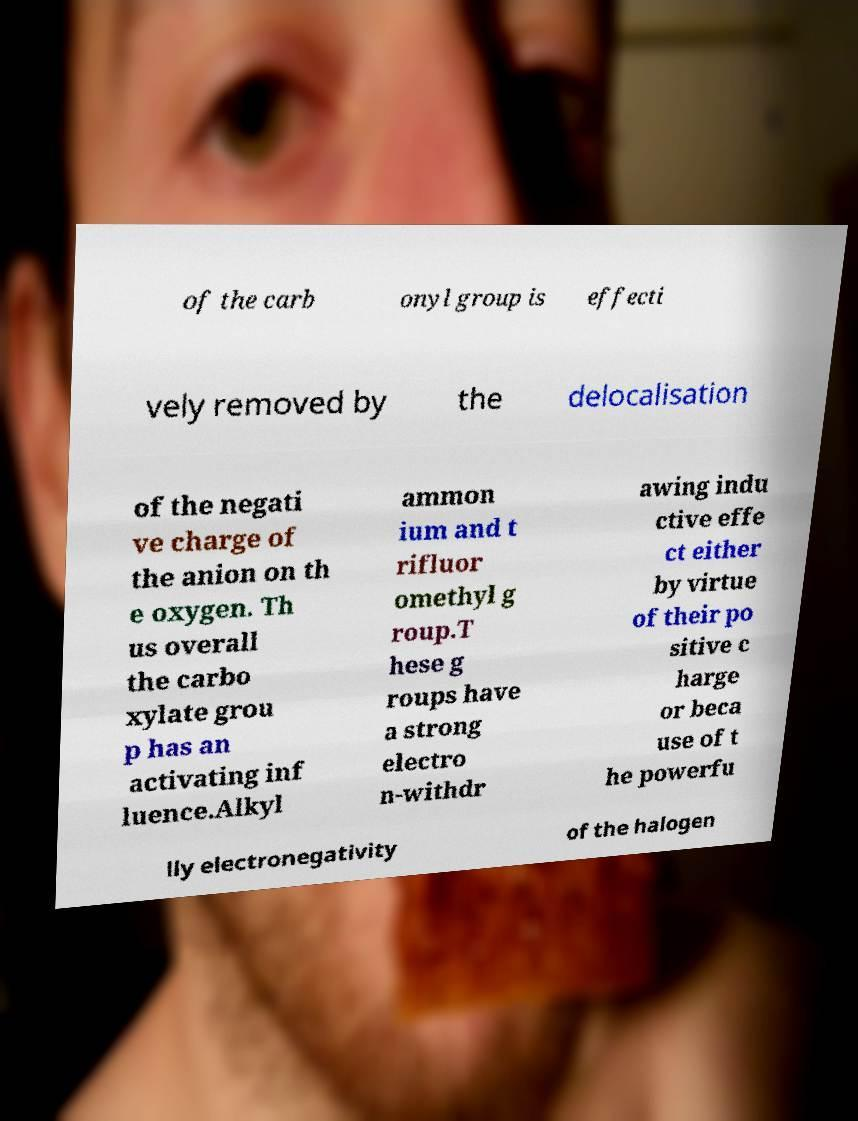Please identify and transcribe the text found in this image. of the carb onyl group is effecti vely removed by the delocalisation of the negati ve charge of the anion on th e oxygen. Th us overall the carbo xylate grou p has an activating inf luence.Alkyl ammon ium and t rifluor omethyl g roup.T hese g roups have a strong electro n-withdr awing indu ctive effe ct either by virtue of their po sitive c harge or beca use of t he powerfu lly electronegativity of the halogen 